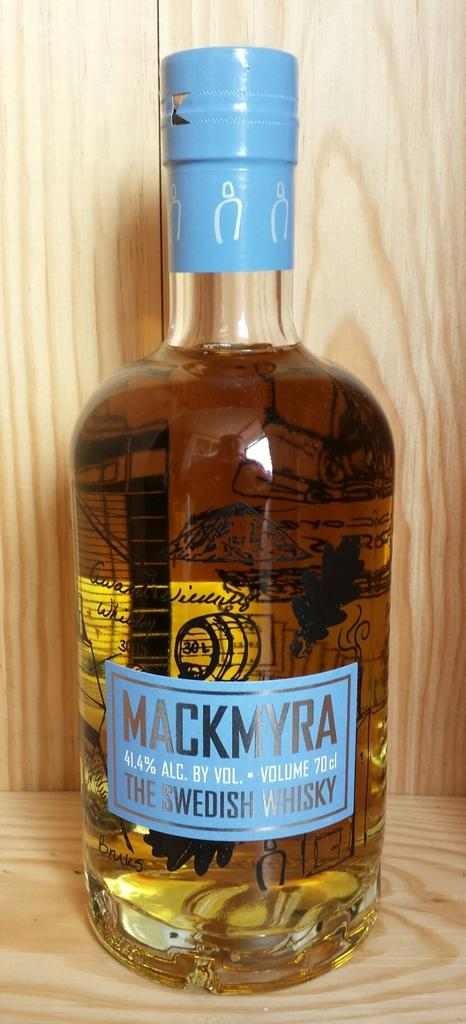What object is present in the image that can hold a liquid? There is a bottle in the image that can hold a liquid. What is inside the bottle? The bottle is filled with a drink. How can the drink be identified? There is a label on the bottle with written text on it. How many legs can be seen supporting the bottle in the image? There are no legs visible in the image; the bottle is likely resting on a surface. 